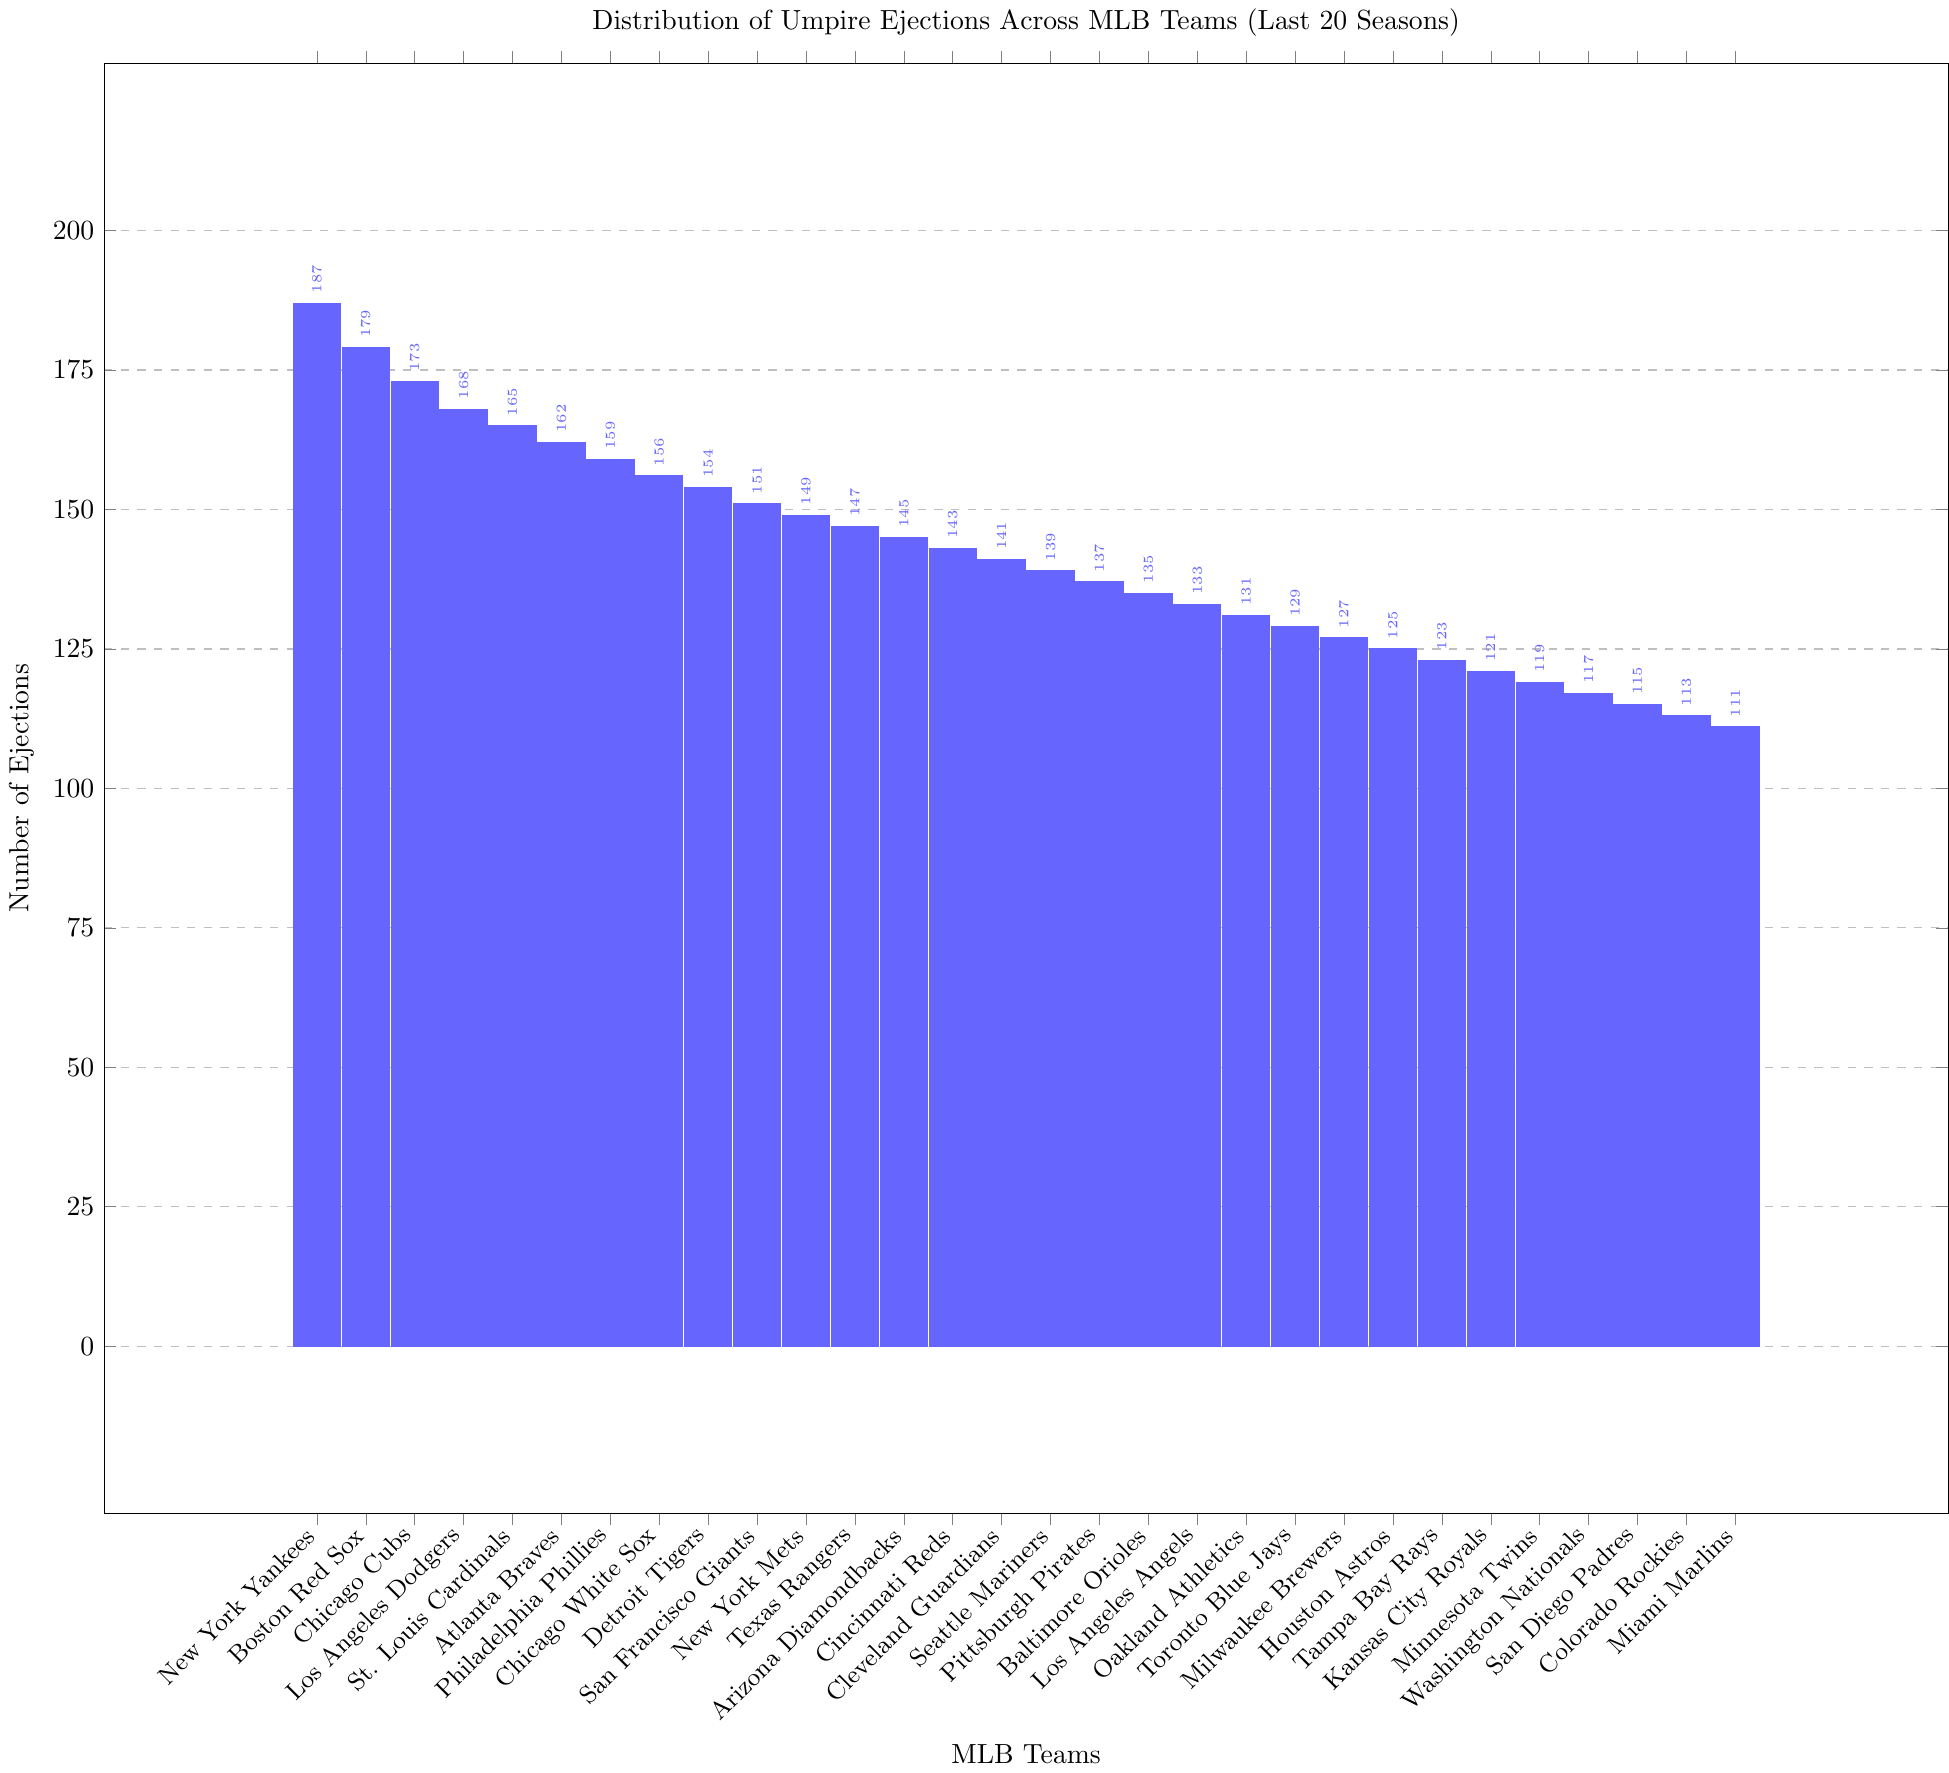What is the team with the highest number of umpire ejections in the last 20 seasons? The team with the highest number of umpire ejections is identified by looking for the tallest bar in the chart, which corresponds to the New York Yankees.
Answer: New York Yankees What is the difference in the number of ejections between the New York Yankees and the Miami Marlins? Subtract the number of ejections for the Miami Marlins from the number for the New York Yankees, i.e., 187 - 111.
Answer: 76 Which teams have more than 150 ejections? Identify all the bars taller than the line marking 150 ejections. These are the New York Yankees, Boston Red Sox, Chicago Cubs, Los Angeles Dodgers, St. Louis Cardinals, Atlanta Braves, Philadelphia Phillies, Chicago White Sox, Detroit Tigers, San Francisco Giants, and New York Mets.
Answer: New York Yankees, Boston Red Sox, Chicago Cubs, Los Angeles Dodgers, St. Louis Cardinals, Atlanta Braves, Philadelphia Phillies, Chicago White Sox, Detroit Tigers, San Francisco Giants, New York Mets How many teams have fewer than 130 ejections? Count all the bars shorter than the line marking 130 ejections. Teams below 130 ejections include Toronto Blue Jays, Milwaukee Brewers, Houston Astros, Tampa Bay Rays, Kansas City Royals, Minnesota Twins, Washington Nationals, San Diego Padres, Colorado Rockies, and Miami Marlins, making a total of 10 teams.
Answer: 10 What is the combined number of ejections for the Chicago Cubs and the Los Angeles Dodgers? Sum the number of ejections for the Chicago Cubs and the Los Angeles Dodgers, i.e., 173 + 168.
Answer: 341 Which team has the closest number of ejections to the San Francisco Giants? Find the ejection count for the San Francisco Giants, which is 151, and look for the team with the nearest number. The New York Mets have 149 ejections, which is the closest.
Answer: New York Mets Are there more teams with fewer than 140 ejections or more than 140 ejections? Count the teams with fewer than 140 ejections (Toronto Blue Jays, Milwaukee Brewers, Houston Astros, Tampa Bay Rays, Kansas City Royals, Minnesota Twins, Washington Nationals, San Diego Padres, Colorado Rockies, Miami Marlins) and those with more than 140 ejections (the remaining teams) and compare. There are 10 teams with fewer than 140 ejections and 20 teams with more.
Answer: More than 140 ejections What is the median number of ejections? List all ejection counts in ascending order and find the middle value. The ordered list is: 111, 113, 115, 117, 119, 121, 123, 125, 127, 129, 131, 133, 135, 137, 139, 141, 143, 145, 147, 149, 151, 154, 156, 159, 162, 165, 168, 173, 179, 187. There are 30 values, so the median is the average of the 15th and 16th values: (139 + 141) / 2.
Answer: 140 What's the average number of ejections across all teams? Sum the total number of ejections and divide by the number of teams. The sum of ejections is 187 + 179 + 173 + 168 + 165 + 162 + 159 + 156 + 154 + 151 + 149 + 147 + 145 + 143 + 141 + 139 + 137 + 135 + 133 + 131 + 129 + 127 + 125 + 123 + 121 + 119 + 117 + 115 + 113 + 111 = 4483. Dividing by 30 teams gives 4483/30.
Answer: 149.43 